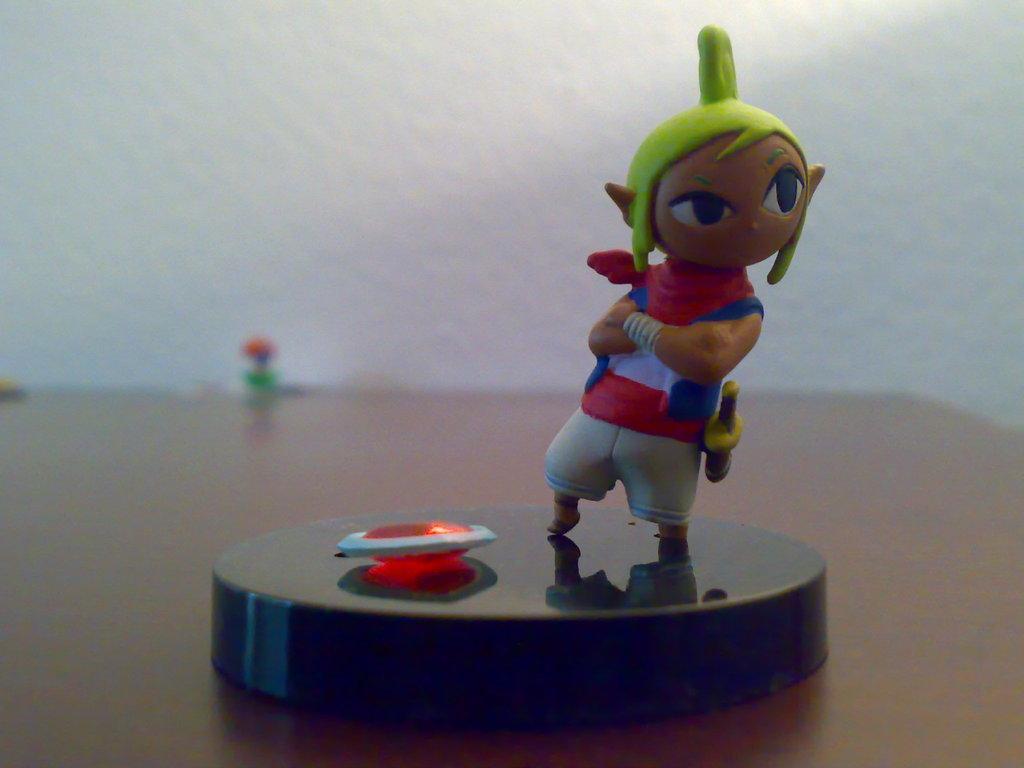Describe this image in one or two sentences. In this image I can see a toy on the table. In the background, I can see the wall. 